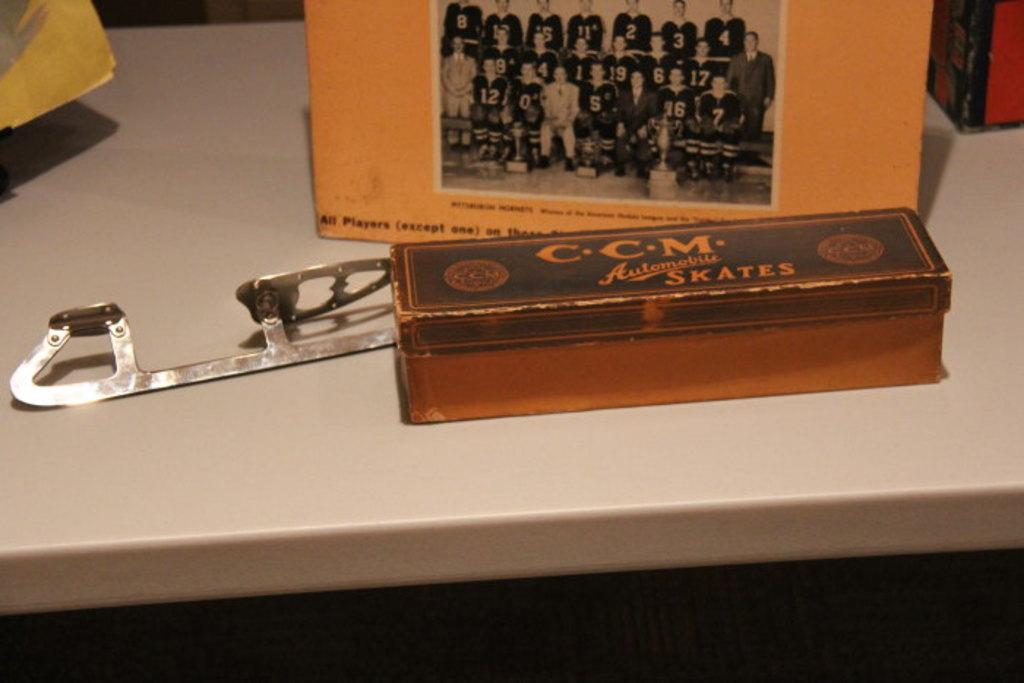<image>
Create a compact narrative representing the image presented. CCM Automobile Skates are branded on this old box. 